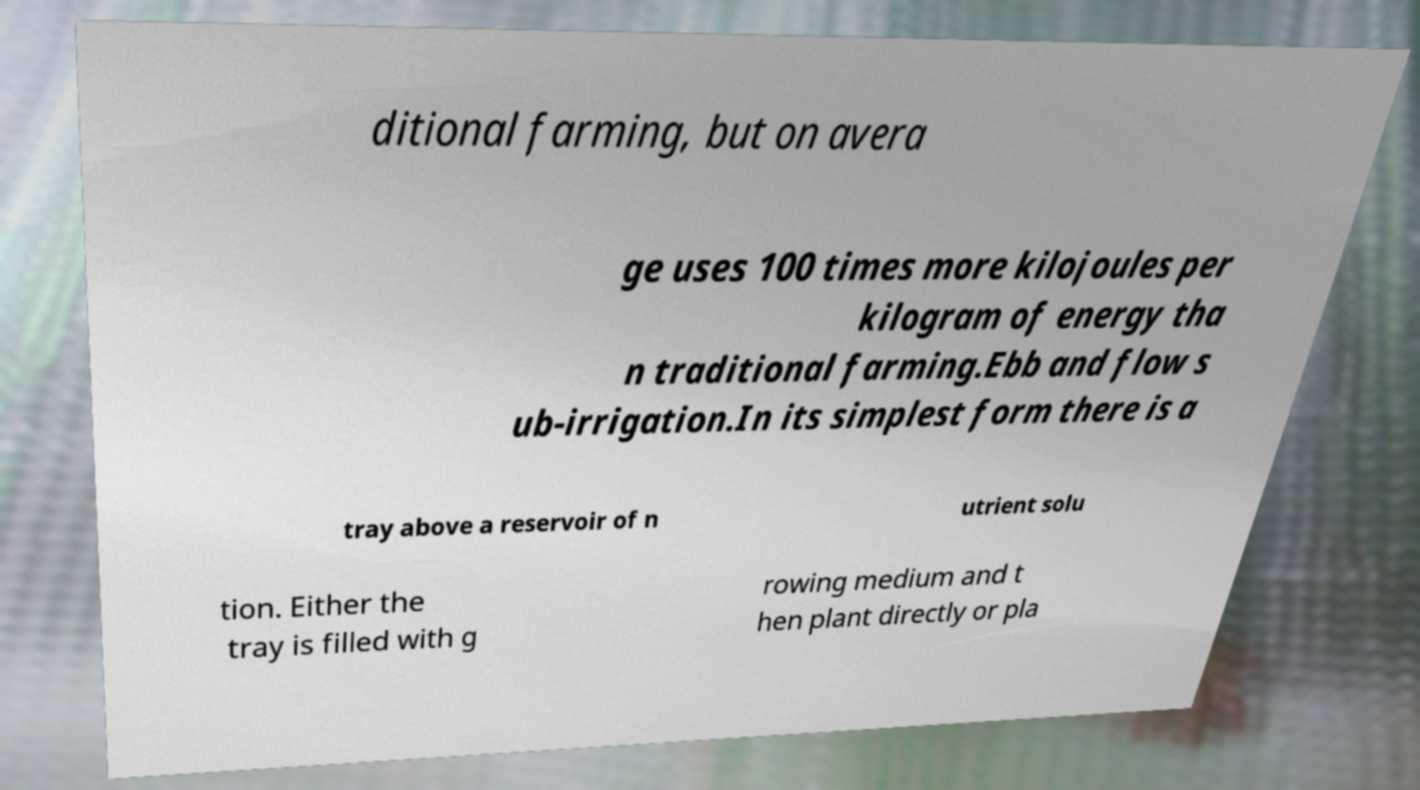For documentation purposes, I need the text within this image transcribed. Could you provide that? ditional farming, but on avera ge uses 100 times more kilojoules per kilogram of energy tha n traditional farming.Ebb and flow s ub-irrigation.In its simplest form there is a tray above a reservoir of n utrient solu tion. Either the tray is filled with g rowing medium and t hen plant directly or pla 